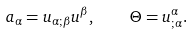<formula> <loc_0><loc_0><loc_500><loc_500>a _ { \alpha } = u _ { \alpha ; \beta } u ^ { \beta } , \quad \Theta = u ^ { \alpha } _ { ; \alpha } .</formula> 